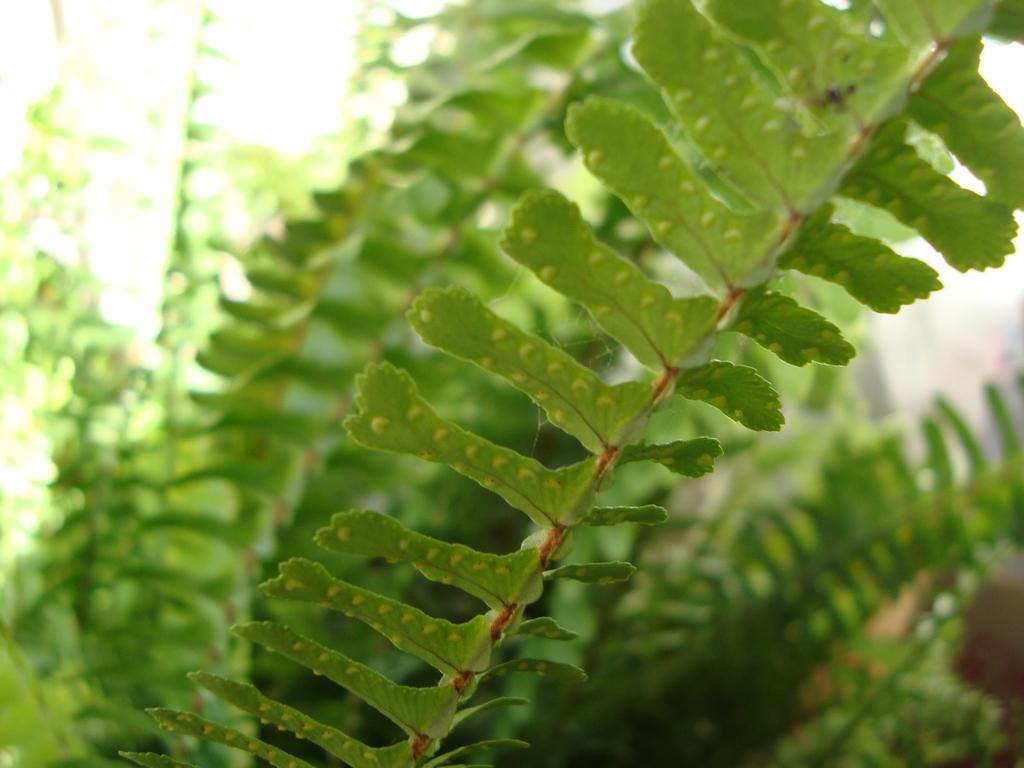What type of living organisms can be seen in the image? Plants can be seen in the image. What is the color of the plants in the image? The plants are green in color. What part of the natural environment is visible in the image? The sky is visible in the image. What is the color of the sky in the image? The sky is white in color. What time of day is it in the image, given that it is morning? The provided facts do not mention the time of day, and there is no indication of morning in the image. 